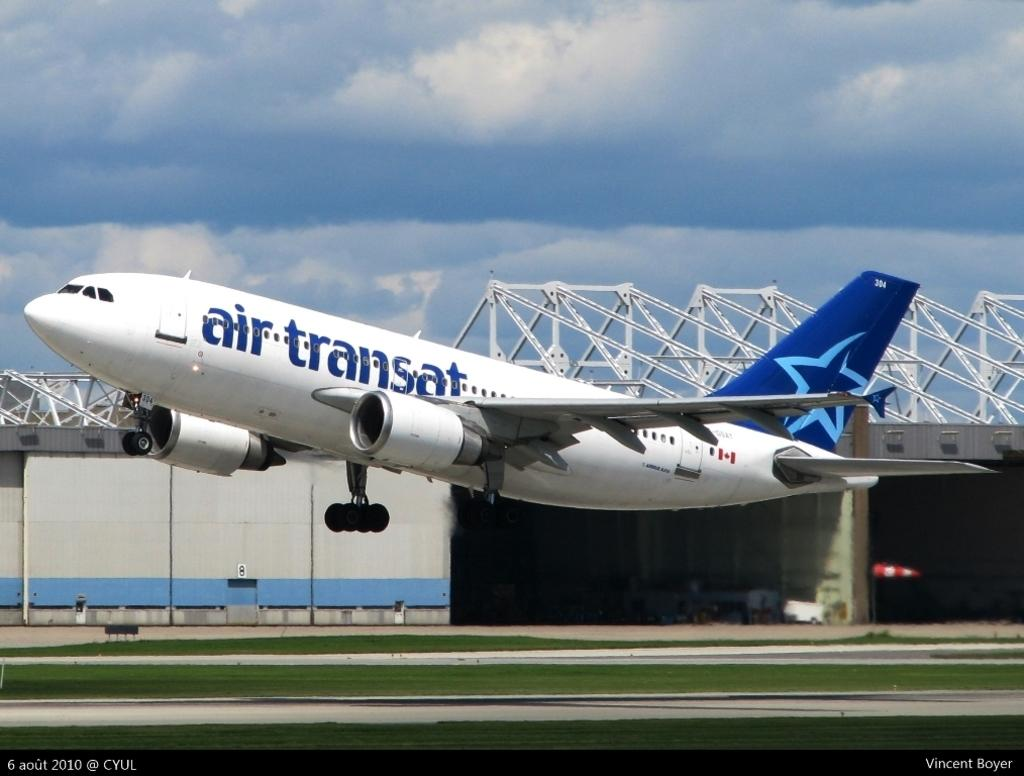What is the main subject in the center of the image? There is an airplane in the center of the image. What type of landscape can be seen at the bottom of the image? There is grass land at the bottom side of the image. What can be observed in the background area of the image? There is a boundary in the background area of the image. How many cards are glued together to form the airplane in the image? There are no cards or glue present in the image; it is an actual airplane. What type of fruit can be seen growing on the grass land in the image? There are no fruits, such as oranges, visible on the grass land in the image. 